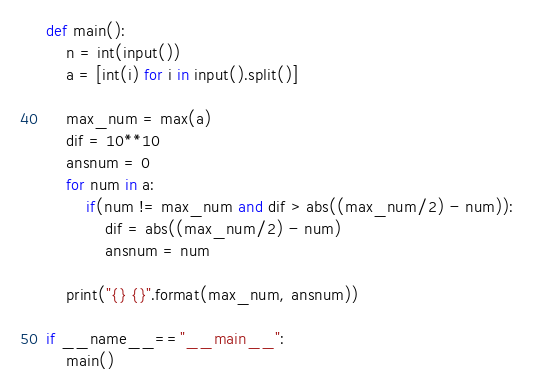<code> <loc_0><loc_0><loc_500><loc_500><_Python_>def main():
    n = int(input())
    a = [int(i) for i in input().split()]
    
    max_num = max(a)
    dif = 10**10
    ansnum = 0
    for num in a:
        if(num != max_num and dif > abs((max_num/2) - num)):
            dif = abs((max_num/2) - num)
            ansnum = num
            
    print("{} {}".format(max_num, ansnum))
        
if __name__=="__main__":
    main()</code> 